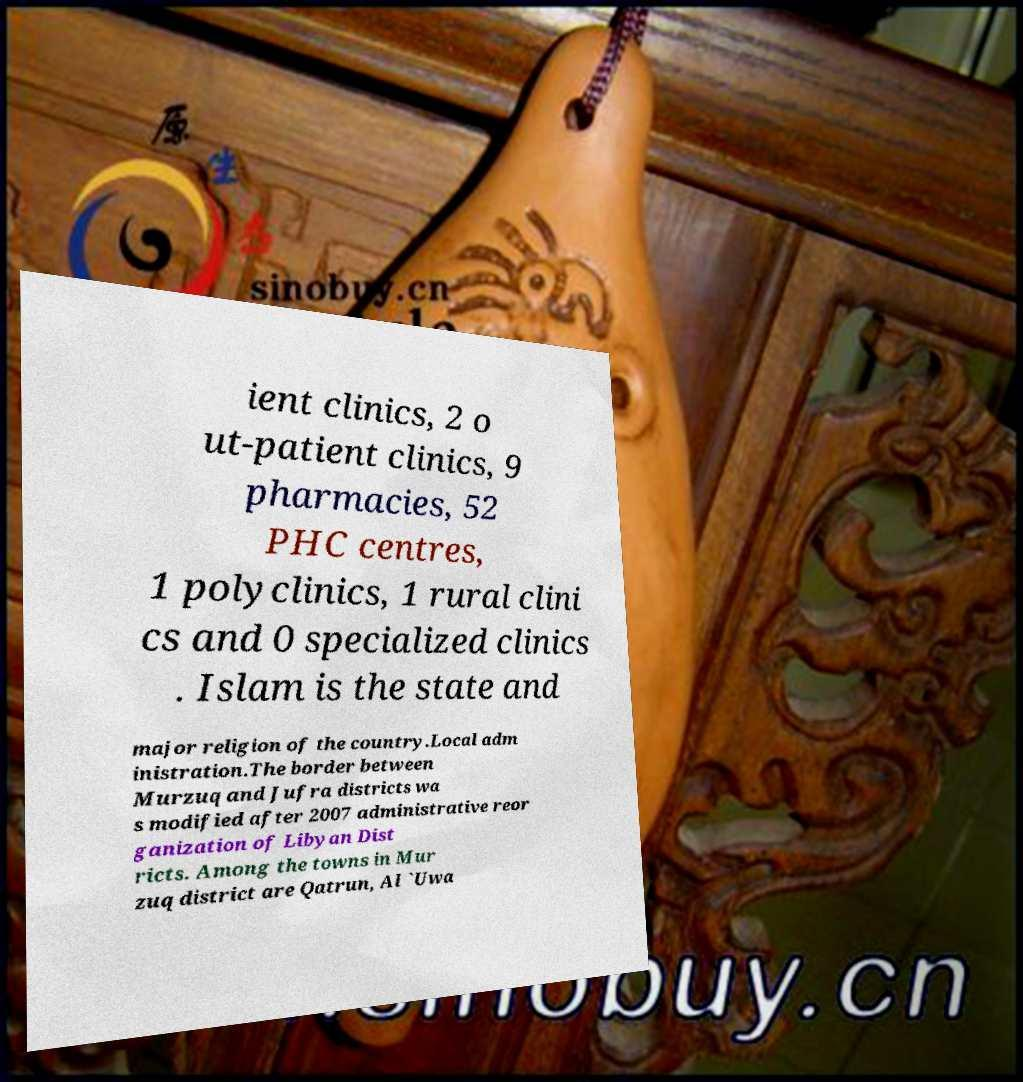There's text embedded in this image that I need extracted. Can you transcribe it verbatim? ient clinics, 2 o ut-patient clinics, 9 pharmacies, 52 PHC centres, 1 polyclinics, 1 rural clini cs and 0 specialized clinics . Islam is the state and major religion of the country.Local adm inistration.The border between Murzuq and Jufra districts wa s modified after 2007 administrative reor ganization of Libyan Dist ricts. Among the towns in Mur zuq district are Qatrun, Al `Uwa 